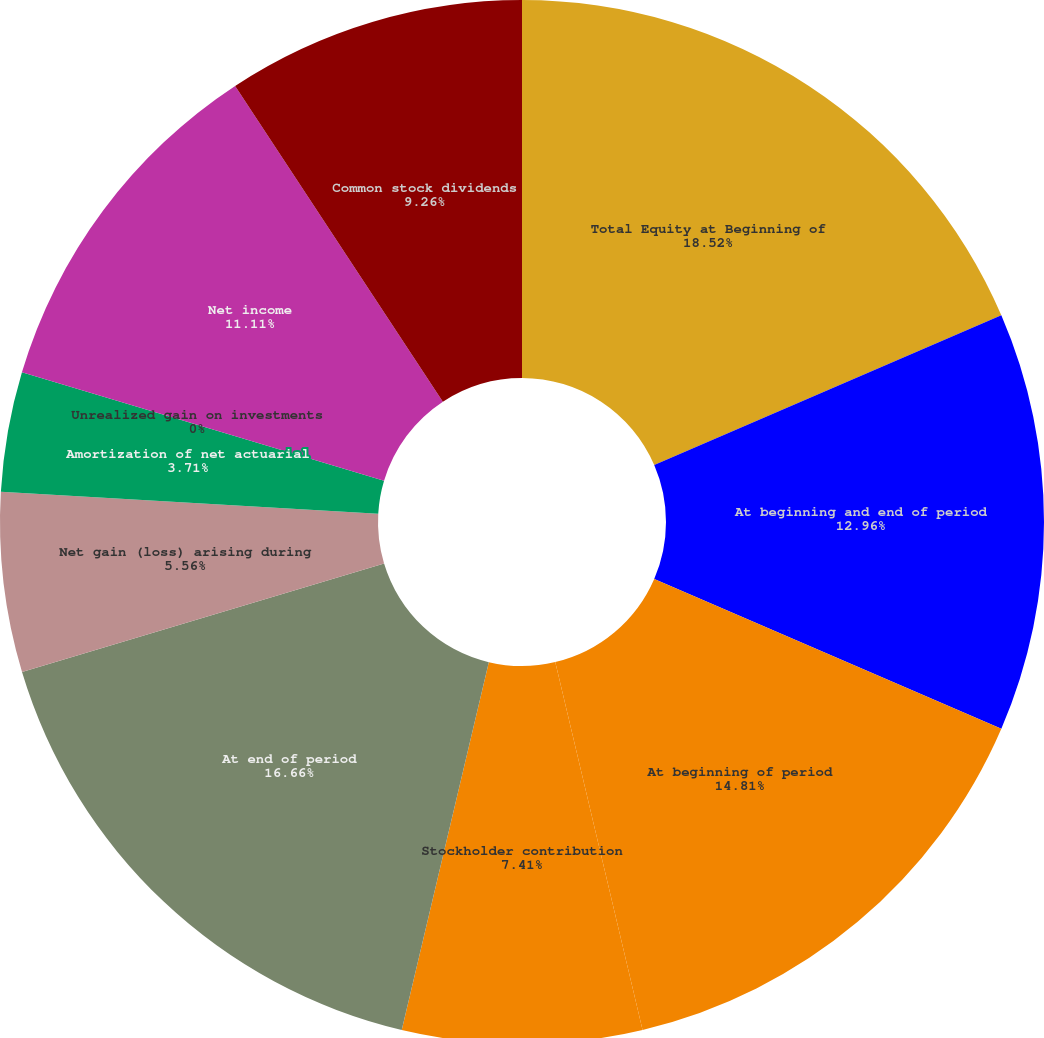Convert chart. <chart><loc_0><loc_0><loc_500><loc_500><pie_chart><fcel>Total Equity at Beginning of<fcel>At beginning and end of period<fcel>At beginning of period<fcel>Stockholder contribution<fcel>At end of period<fcel>Net gain (loss) arising during<fcel>Amortization of net actuarial<fcel>Unrealized gain on investments<fcel>Net income<fcel>Common stock dividends<nl><fcel>18.52%<fcel>12.96%<fcel>14.81%<fcel>7.41%<fcel>16.66%<fcel>5.56%<fcel>3.71%<fcel>0.0%<fcel>11.11%<fcel>9.26%<nl></chart> 